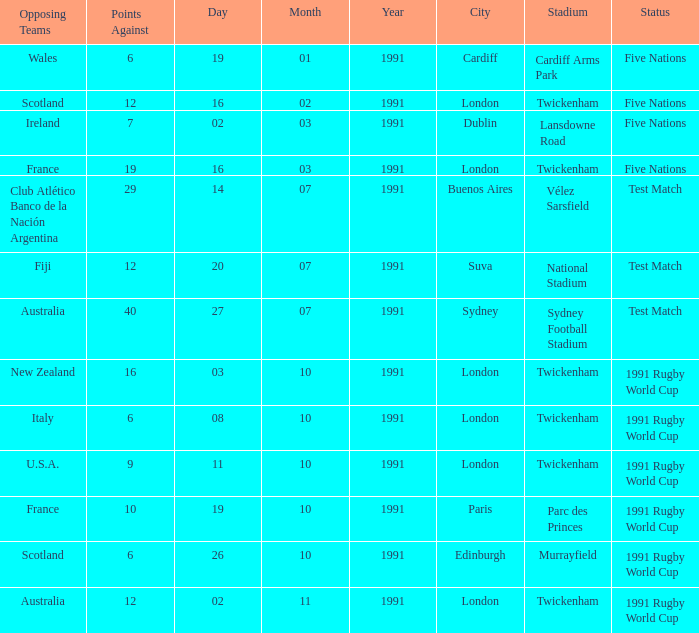What is Date, when Opposing Teams is "Australia", and when Venue is "Twickenham , London"? 02/11/1991. 